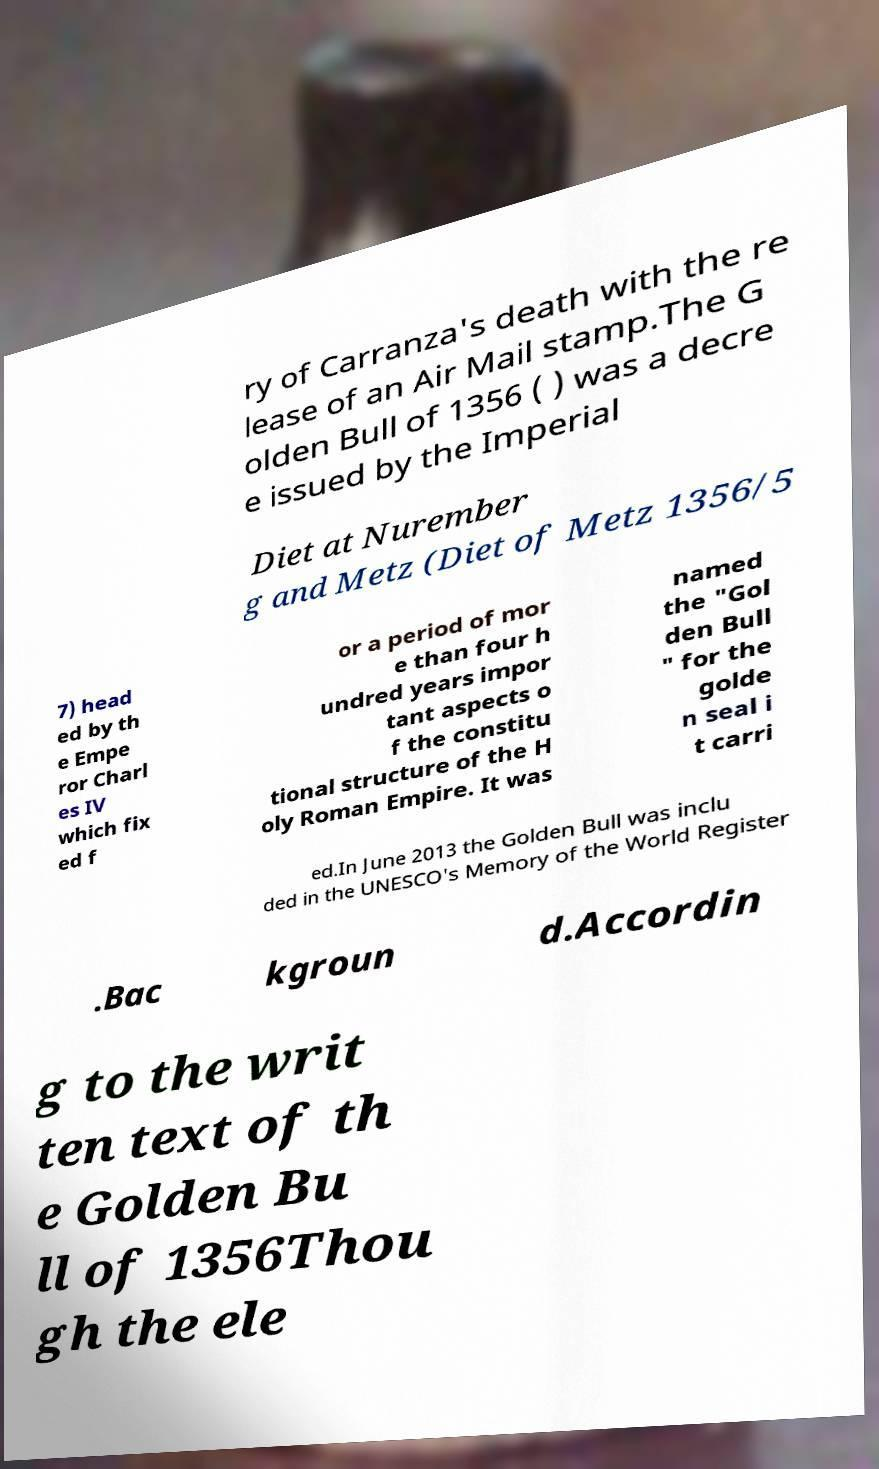There's text embedded in this image that I need extracted. Can you transcribe it verbatim? ry of Carranza's death with the re lease of an Air Mail stamp.The G olden Bull of 1356 ( ) was a decre e issued by the Imperial Diet at Nurember g and Metz (Diet of Metz 1356/5 7) head ed by th e Empe ror Charl es IV which fix ed f or a period of mor e than four h undred years impor tant aspects o f the constitu tional structure of the H oly Roman Empire. It was named the "Gol den Bull " for the golde n seal i t carri ed.In June 2013 the Golden Bull was inclu ded in the UNESCO's Memory of the World Register .Bac kgroun d.Accordin g to the writ ten text of th e Golden Bu ll of 1356Thou gh the ele 